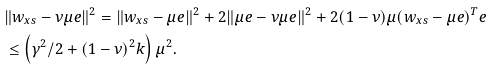<formula> <loc_0><loc_0><loc_500><loc_500>& \| w _ { x s } - \nu \mu e \| ^ { 2 } = \| w _ { x s } - \mu e \| ^ { 2 } + 2 \| \mu e - \nu \mu e \| ^ { 2 } + 2 ( 1 - \nu ) \mu ( w _ { x s } - \mu e ) ^ { T } e \\ & \leq \left ( \gamma ^ { 2 } / 2 + ( 1 - \nu ) ^ { 2 } k \right ) \mu ^ { 2 } .</formula> 